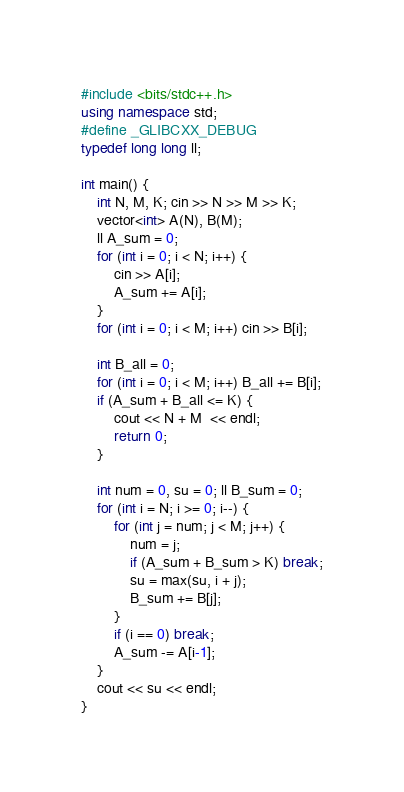Convert code to text. <code><loc_0><loc_0><loc_500><loc_500><_C++_>#include <bits/stdc++.h>
using namespace std;
#define _GLIBCXX_DEBUG
typedef long long ll;

int main() {
    int N, M, K; cin >> N >> M >> K;
    vector<int> A(N), B(M);
    ll A_sum = 0;
    for (int i = 0; i < N; i++) {
        cin >> A[i];
        A_sum += A[i];
    }
    for (int i = 0; i < M; i++) cin >> B[i];

    int B_all = 0;
    for (int i = 0; i < M; i++) B_all += B[i];
    if (A_sum + B_all <= K) {
        cout << N + M  << endl;
        return 0;
    }

    int num = 0, su = 0; ll B_sum = 0;
    for (int i = N; i >= 0; i--) {
        for (int j = num; j < M; j++) {
            num = j;
            if (A_sum + B_sum > K) break;
            su = max(su, i + j);
            B_sum += B[j];
        }
        if (i == 0) break;
        A_sum -= A[i-1];
    }
    cout << su << endl;
}</code> 